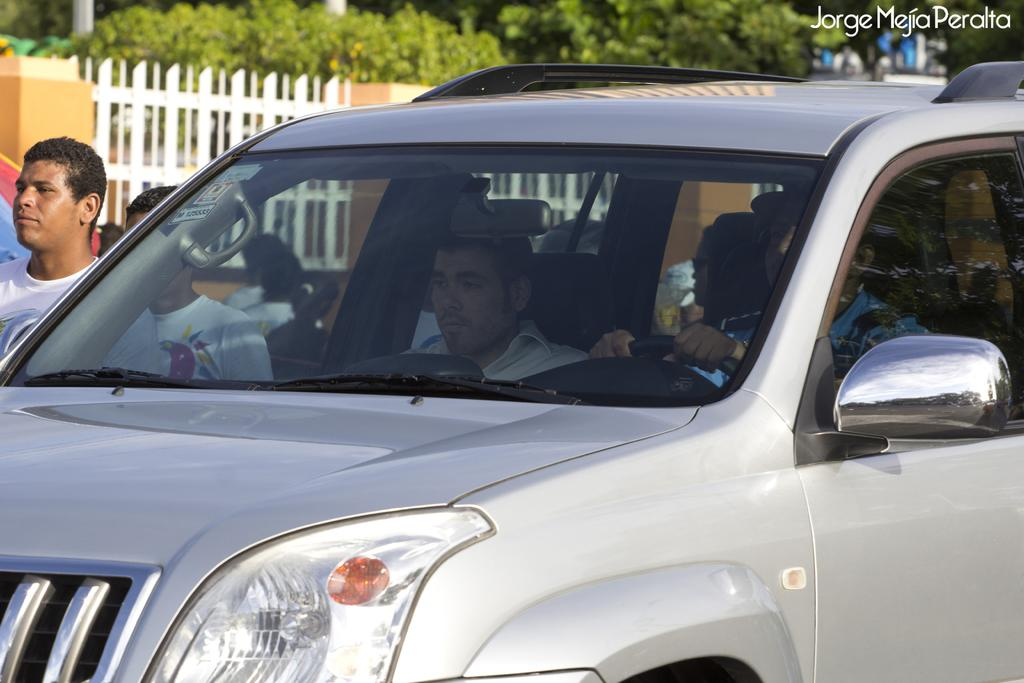How many people are inside the car in the image? There are two people sitting inside the car. What is the color of the car? The car is silver in color. What is happening outside the car in the image? There are people standing beside the car. What can be seen in the background of the image? There are trees and wooden fencing visible in the background. What type of dress is the car wearing in the image? Cars do not wear dresses; the car is silver in color and has no clothing. 